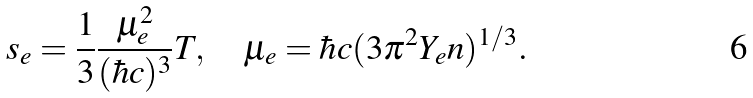<formula> <loc_0><loc_0><loc_500><loc_500>s _ { e } = \frac { 1 } { 3 } \frac { \mu _ { e } ^ { 2 } } { ( \hbar { c } ) ^ { 3 } } T , \quad \mu _ { e } = \hbar { c } ( 3 \pi ^ { 2 } Y _ { e } n ) ^ { 1 / 3 } .</formula> 